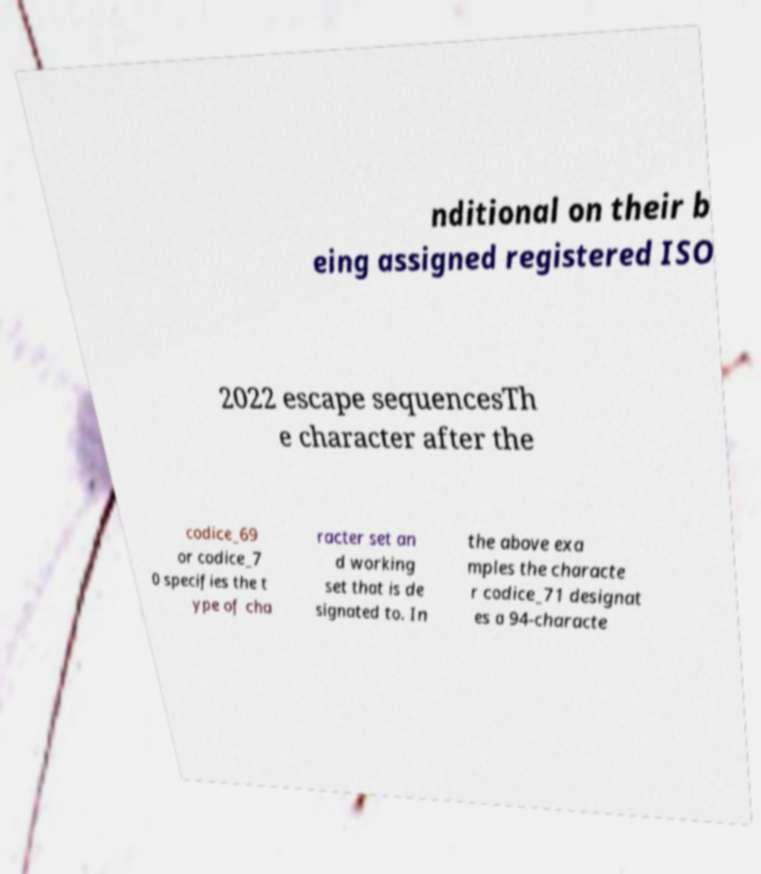Can you accurately transcribe the text from the provided image for me? nditional on their b eing assigned registered ISO 2022 escape sequencesTh e character after the codice_69 or codice_7 0 specifies the t ype of cha racter set an d working set that is de signated to. In the above exa mples the characte r codice_71 designat es a 94-characte 